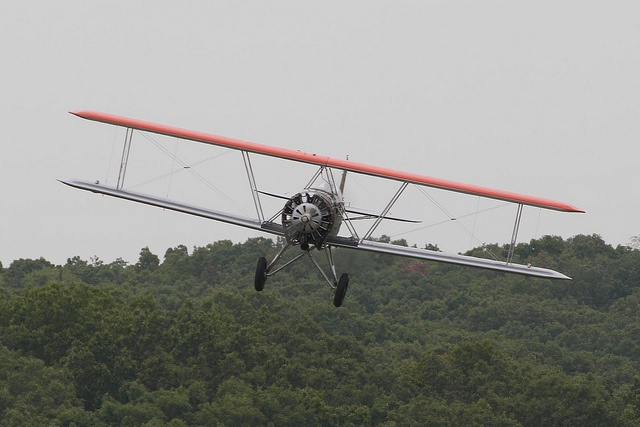Describe the objects in this image and their specific colors. I can see a airplane in lightgray, gray, darkgray, and black tones in this image. 